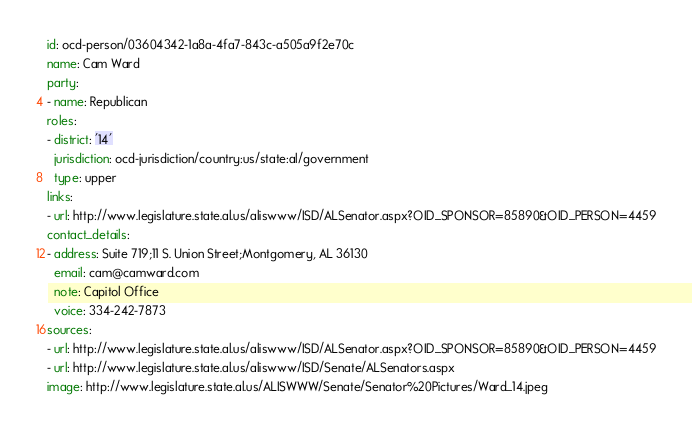<code> <loc_0><loc_0><loc_500><loc_500><_YAML_>id: ocd-person/03604342-1a8a-4fa7-843c-a505a9f2e70c
name: Cam Ward
party:
- name: Republican
roles:
- district: '14'
  jurisdiction: ocd-jurisdiction/country:us/state:al/government
  type: upper
links:
- url: http://www.legislature.state.al.us/aliswww/ISD/ALSenator.aspx?OID_SPONSOR=85890&OID_PERSON=4459
contact_details:
- address: Suite 719;11 S. Union Street;Montgomery, AL 36130
  email: cam@camward.com
  note: Capitol Office
  voice: 334-242-7873
sources:
- url: http://www.legislature.state.al.us/aliswww/ISD/ALSenator.aspx?OID_SPONSOR=85890&OID_PERSON=4459
- url: http://www.legislature.state.al.us/aliswww/ISD/Senate/ALSenators.aspx
image: http://www.legislature.state.al.us/ALISWWW/Senate/Senator%20Pictures/Ward_14.jpeg
</code> 